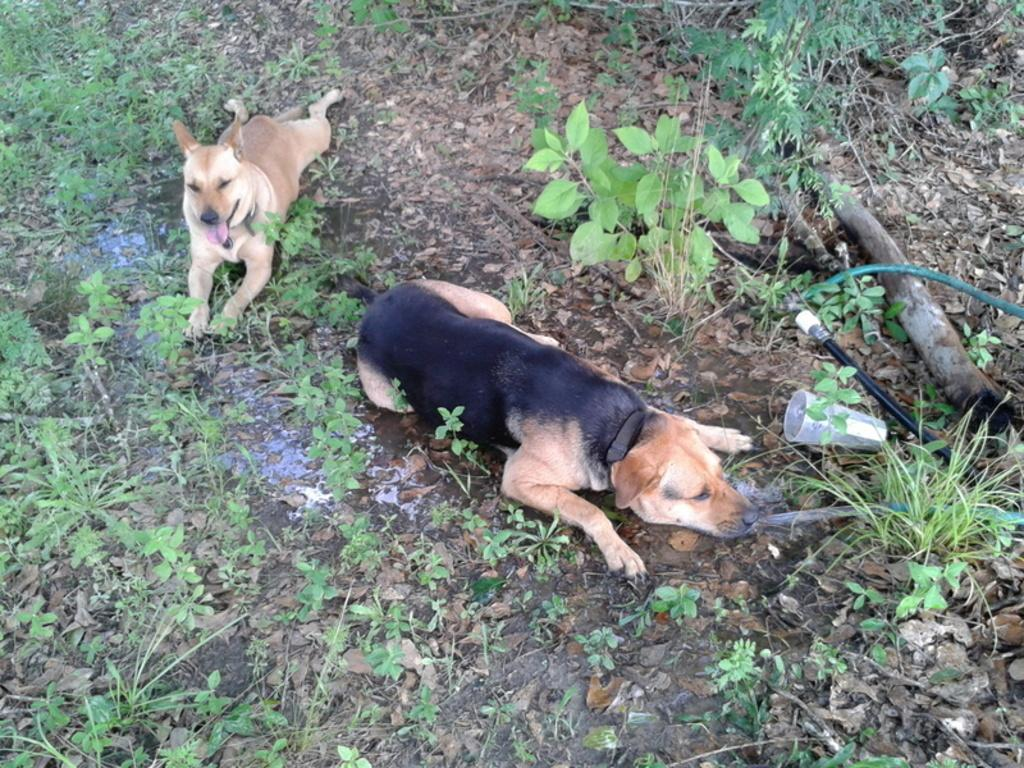What animals are in the center of the image? There are dogs in the center of the image. What type of vegetation or natural elements can be seen at the bottom of the image? There are plants and dry leaves at the bottom of the image. What is the texture or material visible on the right side of the image? There is tree bark on the right side of the image. Can you describe any man-made objects in the image? There is a pipe in the image. What type of iron can be seen being smashed by the dogs in the image? There is no iron present in the image, nor are the dogs smashing anything. 